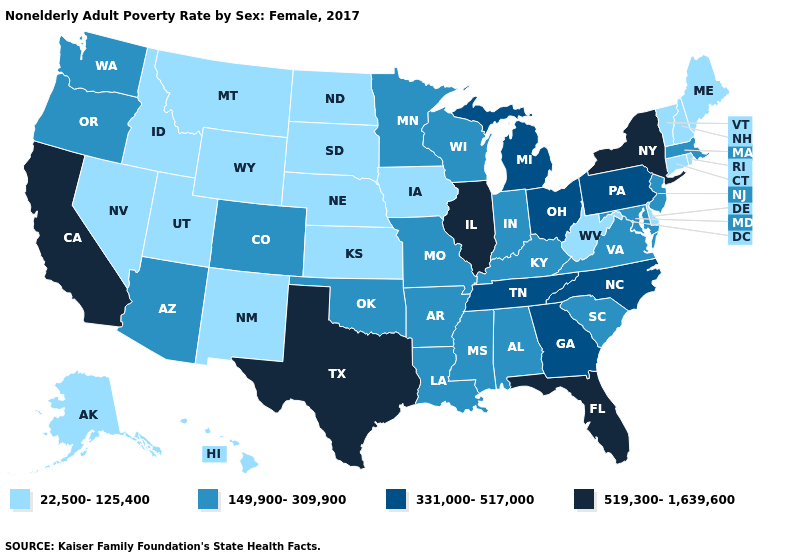What is the value of Oregon?
Quick response, please. 149,900-309,900. What is the value of North Carolina?
Give a very brief answer. 331,000-517,000. Which states have the lowest value in the USA?
Write a very short answer. Alaska, Connecticut, Delaware, Hawaii, Idaho, Iowa, Kansas, Maine, Montana, Nebraska, Nevada, New Hampshire, New Mexico, North Dakota, Rhode Island, South Dakota, Utah, Vermont, West Virginia, Wyoming. Among the states that border Minnesota , does Wisconsin have the lowest value?
Be succinct. No. Among the states that border West Virginia , does Kentucky have the highest value?
Quick response, please. No. What is the value of Minnesota?
Quick response, please. 149,900-309,900. What is the lowest value in the USA?
Quick response, please. 22,500-125,400. What is the highest value in the MidWest ?
Short answer required. 519,300-1,639,600. Does the map have missing data?
Short answer required. No. Among the states that border Utah , does Nevada have the highest value?
Concise answer only. No. Does South Carolina have the lowest value in the USA?
Short answer required. No. What is the value of Arkansas?
Answer briefly. 149,900-309,900. What is the lowest value in states that border Oregon?
Concise answer only. 22,500-125,400. What is the highest value in states that border South Dakota?
Quick response, please. 149,900-309,900. What is the value of Indiana?
Give a very brief answer. 149,900-309,900. 